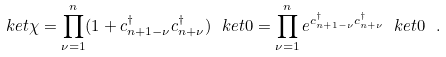<formula> <loc_0><loc_0><loc_500><loc_500>\ k e t { \chi } = \prod _ { \nu = 1 } ^ { n } ( 1 + c _ { n + 1 - \nu } ^ { \dagger } c _ { n + \nu } ^ { \dagger } ) \ k e t { 0 } = \prod _ { \nu = 1 } ^ { n } e ^ { c _ { n + 1 - \nu } ^ { \dagger } c _ { n + \nu } ^ { \dagger } } \ k e t { 0 } \ .</formula> 